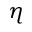<formula> <loc_0><loc_0><loc_500><loc_500>\eta</formula> 